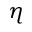<formula> <loc_0><loc_0><loc_500><loc_500>\eta</formula> 